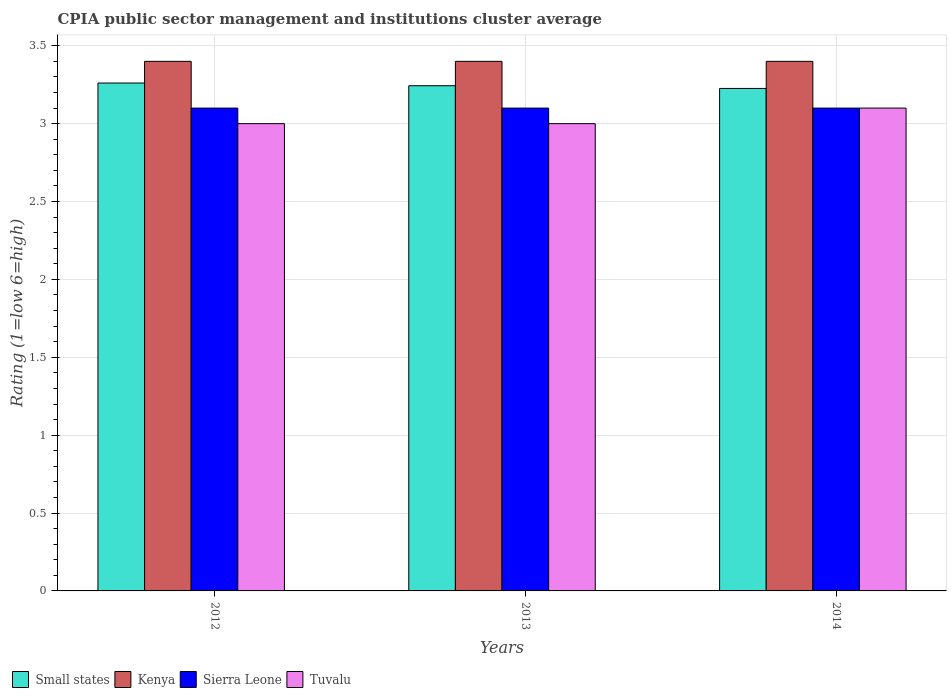How many different coloured bars are there?
Your answer should be very brief. 4. Are the number of bars per tick equal to the number of legend labels?
Your answer should be compact. Yes. How many bars are there on the 2nd tick from the right?
Your response must be concise. 4. In how many cases, is the number of bars for a given year not equal to the number of legend labels?
Ensure brevity in your answer.  0. Across all years, what is the maximum CPIA rating in Small states?
Make the answer very short. 3.26. In which year was the CPIA rating in Kenya maximum?
Provide a succinct answer. 2012. In which year was the CPIA rating in Tuvalu minimum?
Give a very brief answer. 2012. What is the total CPIA rating in Small states in the graph?
Provide a succinct answer. 9.73. What is the difference between the CPIA rating in Kenya in 2012 and that in 2013?
Offer a terse response. 0. What is the difference between the CPIA rating in Sierra Leone in 2012 and the CPIA rating in Kenya in 2013?
Make the answer very short. -0.3. What is the average CPIA rating in Small states per year?
Offer a terse response. 3.24. In the year 2012, what is the difference between the CPIA rating in Sierra Leone and CPIA rating in Tuvalu?
Provide a succinct answer. 0.1. What is the ratio of the CPIA rating in Kenya in 2012 to that in 2013?
Your answer should be compact. 1. Is the CPIA rating in Tuvalu in 2013 less than that in 2014?
Provide a succinct answer. Yes. What is the difference between the highest and the second highest CPIA rating in Small states?
Your response must be concise. 0.02. What is the difference between the highest and the lowest CPIA rating in Tuvalu?
Provide a succinct answer. 0.1. In how many years, is the CPIA rating in Small states greater than the average CPIA rating in Small states taken over all years?
Provide a short and direct response. 2. Is it the case that in every year, the sum of the CPIA rating in Kenya and CPIA rating in Sierra Leone is greater than the sum of CPIA rating in Tuvalu and CPIA rating in Small states?
Your answer should be very brief. Yes. What does the 3rd bar from the left in 2013 represents?
Provide a short and direct response. Sierra Leone. What does the 2nd bar from the right in 2014 represents?
Ensure brevity in your answer.  Sierra Leone. Is it the case that in every year, the sum of the CPIA rating in Sierra Leone and CPIA rating in Kenya is greater than the CPIA rating in Small states?
Make the answer very short. Yes. How many bars are there?
Your answer should be compact. 12. Are all the bars in the graph horizontal?
Make the answer very short. No. How many years are there in the graph?
Keep it short and to the point. 3. What is the difference between two consecutive major ticks on the Y-axis?
Keep it short and to the point. 0.5. Are the values on the major ticks of Y-axis written in scientific E-notation?
Your answer should be compact. No. Where does the legend appear in the graph?
Ensure brevity in your answer.  Bottom left. How are the legend labels stacked?
Make the answer very short. Horizontal. What is the title of the graph?
Offer a terse response. CPIA public sector management and institutions cluster average. Does "Honduras" appear as one of the legend labels in the graph?
Offer a very short reply. No. What is the label or title of the X-axis?
Ensure brevity in your answer.  Years. What is the label or title of the Y-axis?
Your answer should be very brief. Rating (1=low 6=high). What is the Rating (1=low 6=high) of Small states in 2012?
Offer a very short reply. 3.26. What is the Rating (1=low 6=high) in Small states in 2013?
Provide a short and direct response. 3.24. What is the Rating (1=low 6=high) in Kenya in 2013?
Make the answer very short. 3.4. What is the Rating (1=low 6=high) in Small states in 2014?
Provide a succinct answer. 3.23. What is the Rating (1=low 6=high) in Sierra Leone in 2014?
Your response must be concise. 3.1. What is the Rating (1=low 6=high) in Tuvalu in 2014?
Your answer should be very brief. 3.1. Across all years, what is the maximum Rating (1=low 6=high) in Small states?
Your answer should be compact. 3.26. Across all years, what is the maximum Rating (1=low 6=high) of Kenya?
Ensure brevity in your answer.  3.4. Across all years, what is the minimum Rating (1=low 6=high) of Small states?
Keep it short and to the point. 3.23. Across all years, what is the minimum Rating (1=low 6=high) of Kenya?
Give a very brief answer. 3.4. What is the total Rating (1=low 6=high) of Small states in the graph?
Offer a very short reply. 9.73. What is the total Rating (1=low 6=high) in Kenya in the graph?
Ensure brevity in your answer.  10.2. What is the total Rating (1=low 6=high) of Tuvalu in the graph?
Offer a terse response. 9.1. What is the difference between the Rating (1=low 6=high) in Small states in 2012 and that in 2013?
Your answer should be compact. 0.02. What is the difference between the Rating (1=low 6=high) in Kenya in 2012 and that in 2013?
Ensure brevity in your answer.  0. What is the difference between the Rating (1=low 6=high) in Small states in 2012 and that in 2014?
Ensure brevity in your answer.  0.03. What is the difference between the Rating (1=low 6=high) in Sierra Leone in 2012 and that in 2014?
Keep it short and to the point. 0. What is the difference between the Rating (1=low 6=high) in Small states in 2013 and that in 2014?
Offer a very short reply. 0.02. What is the difference between the Rating (1=low 6=high) in Kenya in 2013 and that in 2014?
Your answer should be compact. 0. What is the difference between the Rating (1=low 6=high) of Sierra Leone in 2013 and that in 2014?
Give a very brief answer. 0. What is the difference between the Rating (1=low 6=high) in Tuvalu in 2013 and that in 2014?
Your response must be concise. -0.1. What is the difference between the Rating (1=low 6=high) of Small states in 2012 and the Rating (1=low 6=high) of Kenya in 2013?
Ensure brevity in your answer.  -0.14. What is the difference between the Rating (1=low 6=high) of Small states in 2012 and the Rating (1=low 6=high) of Sierra Leone in 2013?
Your response must be concise. 0.16. What is the difference between the Rating (1=low 6=high) in Small states in 2012 and the Rating (1=low 6=high) in Tuvalu in 2013?
Offer a terse response. 0.26. What is the difference between the Rating (1=low 6=high) of Kenya in 2012 and the Rating (1=low 6=high) of Tuvalu in 2013?
Ensure brevity in your answer.  0.4. What is the difference between the Rating (1=low 6=high) in Sierra Leone in 2012 and the Rating (1=low 6=high) in Tuvalu in 2013?
Provide a short and direct response. 0.1. What is the difference between the Rating (1=low 6=high) in Small states in 2012 and the Rating (1=low 6=high) in Kenya in 2014?
Ensure brevity in your answer.  -0.14. What is the difference between the Rating (1=low 6=high) in Small states in 2012 and the Rating (1=low 6=high) in Sierra Leone in 2014?
Your answer should be compact. 0.16. What is the difference between the Rating (1=low 6=high) of Small states in 2012 and the Rating (1=low 6=high) of Tuvalu in 2014?
Provide a succinct answer. 0.16. What is the difference between the Rating (1=low 6=high) of Kenya in 2012 and the Rating (1=low 6=high) of Sierra Leone in 2014?
Provide a succinct answer. 0.3. What is the difference between the Rating (1=low 6=high) in Kenya in 2012 and the Rating (1=low 6=high) in Tuvalu in 2014?
Make the answer very short. 0.3. What is the difference between the Rating (1=low 6=high) of Sierra Leone in 2012 and the Rating (1=low 6=high) of Tuvalu in 2014?
Offer a very short reply. 0. What is the difference between the Rating (1=low 6=high) in Small states in 2013 and the Rating (1=low 6=high) in Kenya in 2014?
Provide a succinct answer. -0.16. What is the difference between the Rating (1=low 6=high) in Small states in 2013 and the Rating (1=low 6=high) in Sierra Leone in 2014?
Give a very brief answer. 0.14. What is the difference between the Rating (1=low 6=high) in Small states in 2013 and the Rating (1=low 6=high) in Tuvalu in 2014?
Offer a very short reply. 0.14. What is the average Rating (1=low 6=high) in Small states per year?
Your answer should be compact. 3.24. What is the average Rating (1=low 6=high) in Kenya per year?
Give a very brief answer. 3.4. What is the average Rating (1=low 6=high) in Tuvalu per year?
Ensure brevity in your answer.  3.03. In the year 2012, what is the difference between the Rating (1=low 6=high) of Small states and Rating (1=low 6=high) of Kenya?
Your answer should be compact. -0.14. In the year 2012, what is the difference between the Rating (1=low 6=high) of Small states and Rating (1=low 6=high) of Sierra Leone?
Your response must be concise. 0.16. In the year 2012, what is the difference between the Rating (1=low 6=high) in Small states and Rating (1=low 6=high) in Tuvalu?
Your answer should be compact. 0.26. In the year 2012, what is the difference between the Rating (1=low 6=high) of Kenya and Rating (1=low 6=high) of Sierra Leone?
Offer a terse response. 0.3. In the year 2013, what is the difference between the Rating (1=low 6=high) in Small states and Rating (1=low 6=high) in Kenya?
Offer a terse response. -0.16. In the year 2013, what is the difference between the Rating (1=low 6=high) of Small states and Rating (1=low 6=high) of Sierra Leone?
Keep it short and to the point. 0.14. In the year 2013, what is the difference between the Rating (1=low 6=high) of Small states and Rating (1=low 6=high) of Tuvalu?
Provide a short and direct response. 0.24. In the year 2013, what is the difference between the Rating (1=low 6=high) of Kenya and Rating (1=low 6=high) of Sierra Leone?
Give a very brief answer. 0.3. In the year 2013, what is the difference between the Rating (1=low 6=high) in Kenya and Rating (1=low 6=high) in Tuvalu?
Your response must be concise. 0.4. In the year 2013, what is the difference between the Rating (1=low 6=high) in Sierra Leone and Rating (1=low 6=high) in Tuvalu?
Provide a succinct answer. 0.1. In the year 2014, what is the difference between the Rating (1=low 6=high) in Small states and Rating (1=low 6=high) in Kenya?
Make the answer very short. -0.17. In the year 2014, what is the difference between the Rating (1=low 6=high) in Small states and Rating (1=low 6=high) in Sierra Leone?
Offer a terse response. 0.13. In the year 2014, what is the difference between the Rating (1=low 6=high) of Small states and Rating (1=low 6=high) of Tuvalu?
Your answer should be compact. 0.13. In the year 2014, what is the difference between the Rating (1=low 6=high) in Kenya and Rating (1=low 6=high) in Sierra Leone?
Give a very brief answer. 0.3. In the year 2014, what is the difference between the Rating (1=low 6=high) of Sierra Leone and Rating (1=low 6=high) of Tuvalu?
Make the answer very short. 0. What is the ratio of the Rating (1=low 6=high) of Small states in 2012 to that in 2013?
Give a very brief answer. 1.01. What is the ratio of the Rating (1=low 6=high) in Kenya in 2012 to that in 2013?
Keep it short and to the point. 1. What is the ratio of the Rating (1=low 6=high) of Tuvalu in 2012 to that in 2013?
Keep it short and to the point. 1. What is the ratio of the Rating (1=low 6=high) in Small states in 2012 to that in 2014?
Provide a short and direct response. 1.01. What is the ratio of the Rating (1=low 6=high) of Small states in 2013 to that in 2014?
Provide a short and direct response. 1.01. What is the ratio of the Rating (1=low 6=high) in Tuvalu in 2013 to that in 2014?
Provide a succinct answer. 0.97. What is the difference between the highest and the second highest Rating (1=low 6=high) in Small states?
Ensure brevity in your answer.  0.02. What is the difference between the highest and the second highest Rating (1=low 6=high) of Kenya?
Keep it short and to the point. 0. What is the difference between the highest and the lowest Rating (1=low 6=high) of Small states?
Your answer should be very brief. 0.03. What is the difference between the highest and the lowest Rating (1=low 6=high) in Sierra Leone?
Provide a succinct answer. 0. What is the difference between the highest and the lowest Rating (1=low 6=high) in Tuvalu?
Offer a terse response. 0.1. 